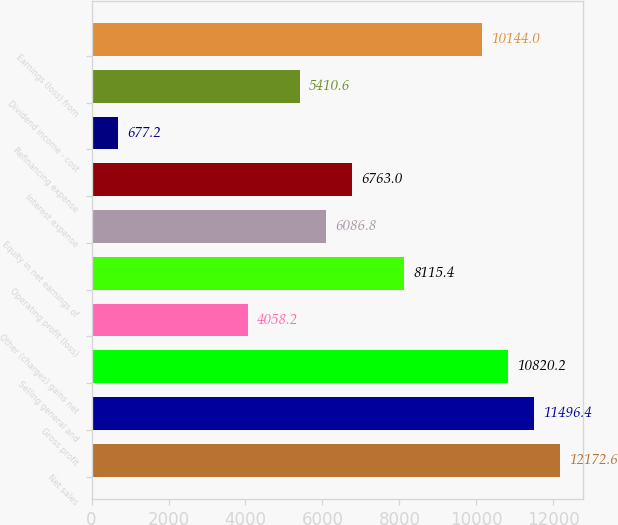<chart> <loc_0><loc_0><loc_500><loc_500><bar_chart><fcel>Net sales<fcel>Gross profit<fcel>Selling general and<fcel>Other (charges) gains net<fcel>Operating profit (loss)<fcel>Equity in net earnings of<fcel>Interest expense<fcel>Refinancing expense<fcel>Dividend income - cost<fcel>Earnings (loss) from<nl><fcel>12172.6<fcel>11496.4<fcel>10820.2<fcel>4058.2<fcel>8115.4<fcel>6086.8<fcel>6763<fcel>677.2<fcel>5410.6<fcel>10144<nl></chart> 